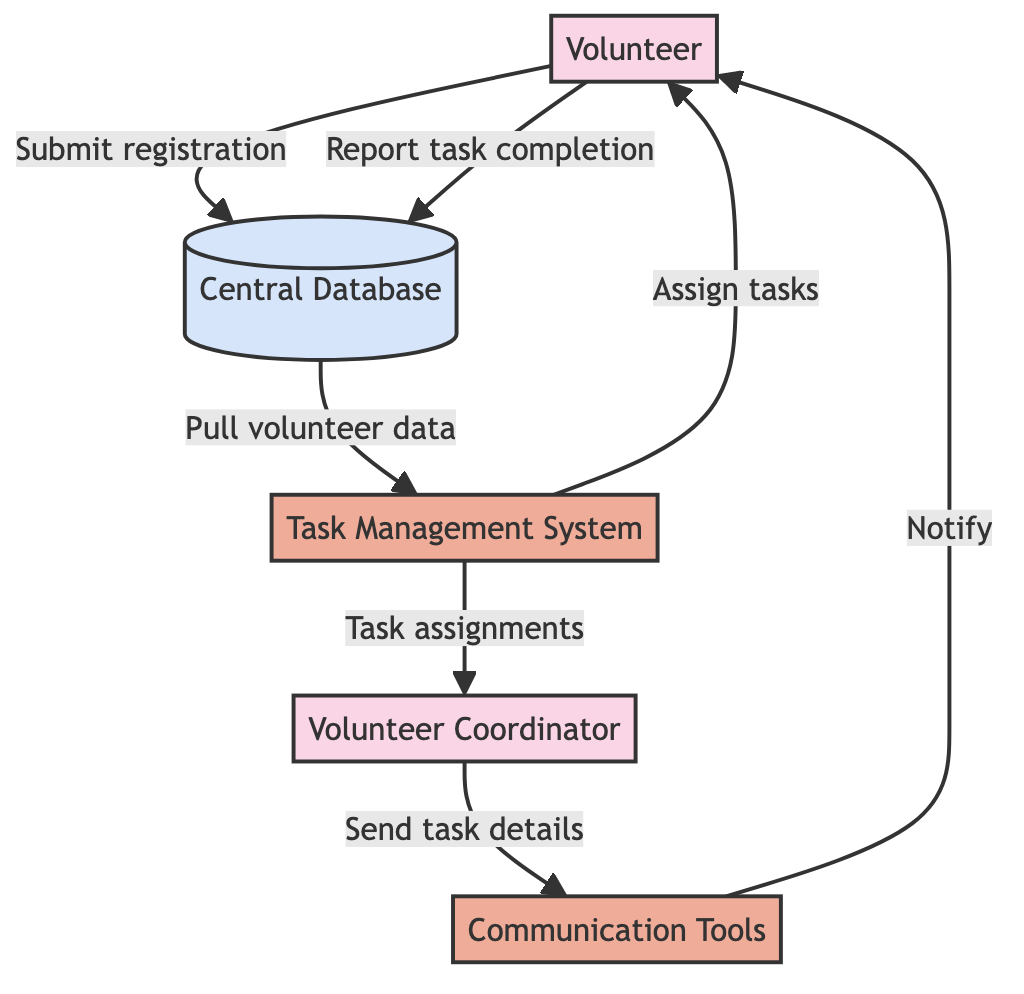What is the role of the Central Database? The Central Database serves as a repository for all volunteer, task, and communication data. It holds information submitted by volunteers, which is then used for matching with tasks, and receives reports of task completions.
Answer: Central repository How many entities are present in the diagram? There are five distinct entities: Volunteer, Volunteer Coordinator, Task Management System, Communication Tools, and Central Database. Counting each one gives a total of five entities.
Answer: Five What data flow occurs after a volunteer submits their registration? After a volunteer submits their registration, the data flows from the Volunteer to the Central Database. This submission is crucial as it updates the database with the volunteer’s information.
Answer: To Central Database Who uses the Communication Tools to notify volunteers? The Volunteer Coordinator is responsible for using the Communication Tools to send task details and notifications to volunteers. This role involves coordination and communication for effective volunteering.
Answer: Volunteer Coordinator What type of information does the Task Management System send to the Volunteer Coordinator? The Task Management System sends task assignments to the Volunteer Coordinator, which helps in managing and coordinating the volunteers effectively for task allocation.
Answer: Task assignments In which direction does the flow go from the Task Management System to the Volunteer? The flow goes from the Task Management System to the Volunteer, indicating that assigned tasks are communicated to the volunteers directly from the Task Management System.
Answer: From Task Management System to Volunteer What process is involved when a volunteer reports back their task completion? The Reporting Task Completion process is what happens when a volunteer submits their completed tasks, and this information is sent back to the Central Database to be recorded.
Answer: Report Task Completion What happens to volunteer data once it reaches the Central Database? The Central Database pulls volunteer data to the Task Management System for task matching. This is a critical step ensuring that volunteers are assigned tasks suitable for them.
Answer: Pulled to Task Management System What is the first interaction a volunteer has in this flow? The first interaction is the Volunteer Sign-Up process, where volunteers register their interest, which initiates their engagement with the platform and leads to further actions.
Answer: Volunteer Sign-Up 